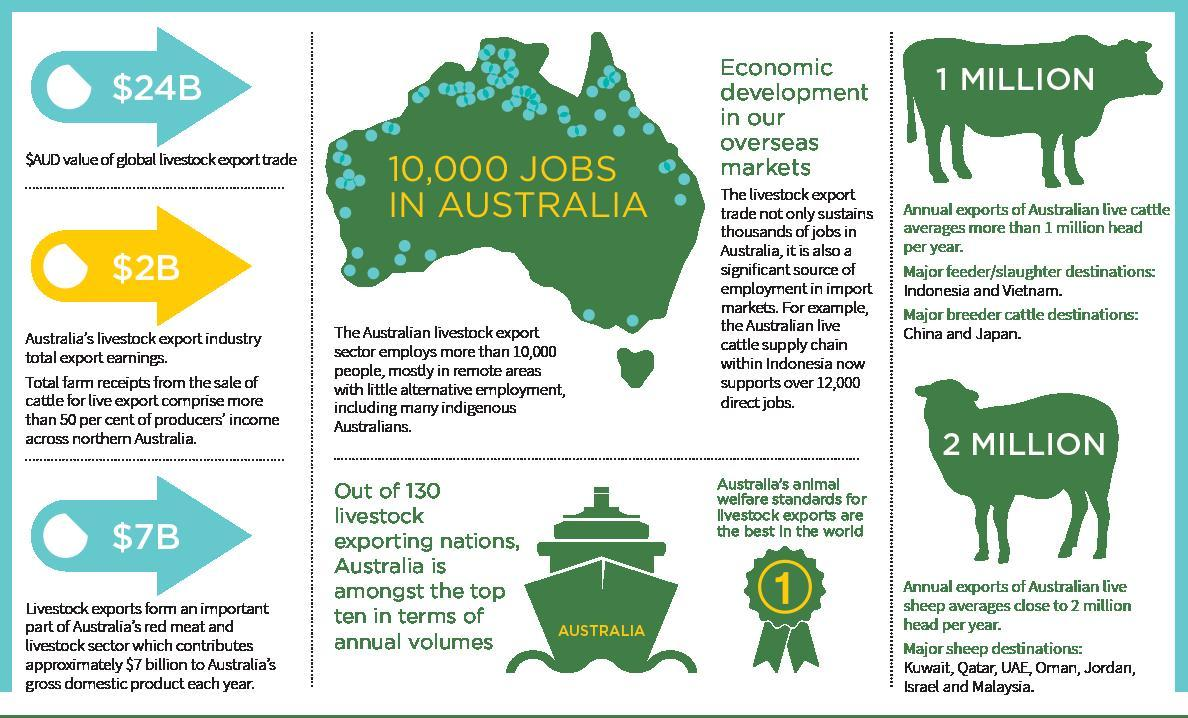How many breeder cattle destinations?
Answer the question with a short phrase. 2 How many major sheep destinations? 7 How many slaughter destinations? 2 